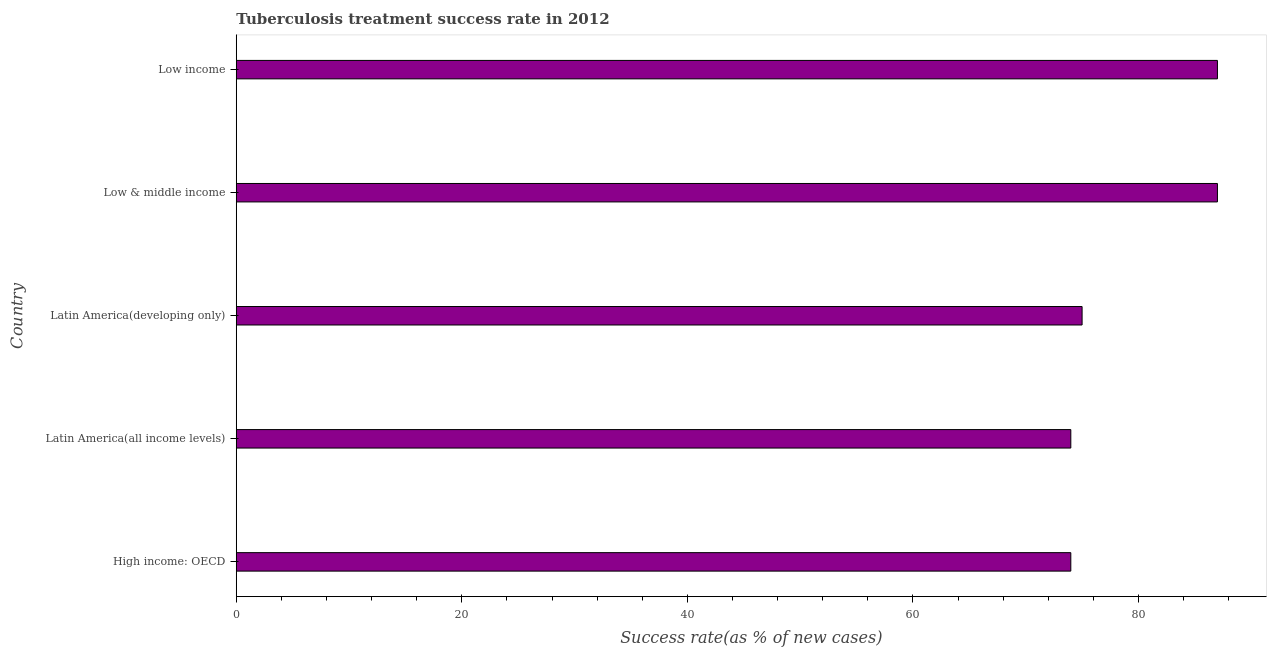Does the graph contain grids?
Your response must be concise. No. What is the title of the graph?
Your answer should be very brief. Tuberculosis treatment success rate in 2012. What is the label or title of the X-axis?
Make the answer very short. Success rate(as % of new cases). What is the tuberculosis treatment success rate in Low income?
Keep it short and to the point. 87. In which country was the tuberculosis treatment success rate maximum?
Your answer should be compact. Low & middle income. In which country was the tuberculosis treatment success rate minimum?
Your response must be concise. High income: OECD. What is the sum of the tuberculosis treatment success rate?
Your answer should be very brief. 397. What is the difference between the tuberculosis treatment success rate in High income: OECD and Low income?
Keep it short and to the point. -13. What is the average tuberculosis treatment success rate per country?
Keep it short and to the point. 79. What is the ratio of the tuberculosis treatment success rate in Latin America(all income levels) to that in Low income?
Offer a very short reply. 0.85. Is the sum of the tuberculosis treatment success rate in High income: OECD and Low income greater than the maximum tuberculosis treatment success rate across all countries?
Ensure brevity in your answer.  Yes. What is the difference between the highest and the lowest tuberculosis treatment success rate?
Your answer should be very brief. 13. What is the difference between two consecutive major ticks on the X-axis?
Your answer should be very brief. 20. What is the Success rate(as % of new cases) in Latin America(all income levels)?
Offer a terse response. 74. What is the Success rate(as % of new cases) of Low & middle income?
Your answer should be compact. 87. What is the Success rate(as % of new cases) of Low income?
Your response must be concise. 87. What is the difference between the Success rate(as % of new cases) in High income: OECD and Latin America(all income levels)?
Your answer should be compact. 0. What is the difference between the Success rate(as % of new cases) in High income: OECD and Low & middle income?
Provide a short and direct response. -13. What is the difference between the Success rate(as % of new cases) in Latin America(all income levels) and Low & middle income?
Offer a very short reply. -13. What is the difference between the Success rate(as % of new cases) in Latin America(all income levels) and Low income?
Your answer should be very brief. -13. What is the difference between the Success rate(as % of new cases) in Latin America(developing only) and Low & middle income?
Offer a terse response. -12. What is the ratio of the Success rate(as % of new cases) in High income: OECD to that in Low & middle income?
Provide a succinct answer. 0.85. What is the ratio of the Success rate(as % of new cases) in High income: OECD to that in Low income?
Your answer should be very brief. 0.85. What is the ratio of the Success rate(as % of new cases) in Latin America(all income levels) to that in Latin America(developing only)?
Offer a very short reply. 0.99. What is the ratio of the Success rate(as % of new cases) in Latin America(all income levels) to that in Low & middle income?
Provide a succinct answer. 0.85. What is the ratio of the Success rate(as % of new cases) in Latin America(all income levels) to that in Low income?
Keep it short and to the point. 0.85. What is the ratio of the Success rate(as % of new cases) in Latin America(developing only) to that in Low & middle income?
Keep it short and to the point. 0.86. What is the ratio of the Success rate(as % of new cases) in Latin America(developing only) to that in Low income?
Your response must be concise. 0.86. What is the ratio of the Success rate(as % of new cases) in Low & middle income to that in Low income?
Ensure brevity in your answer.  1. 